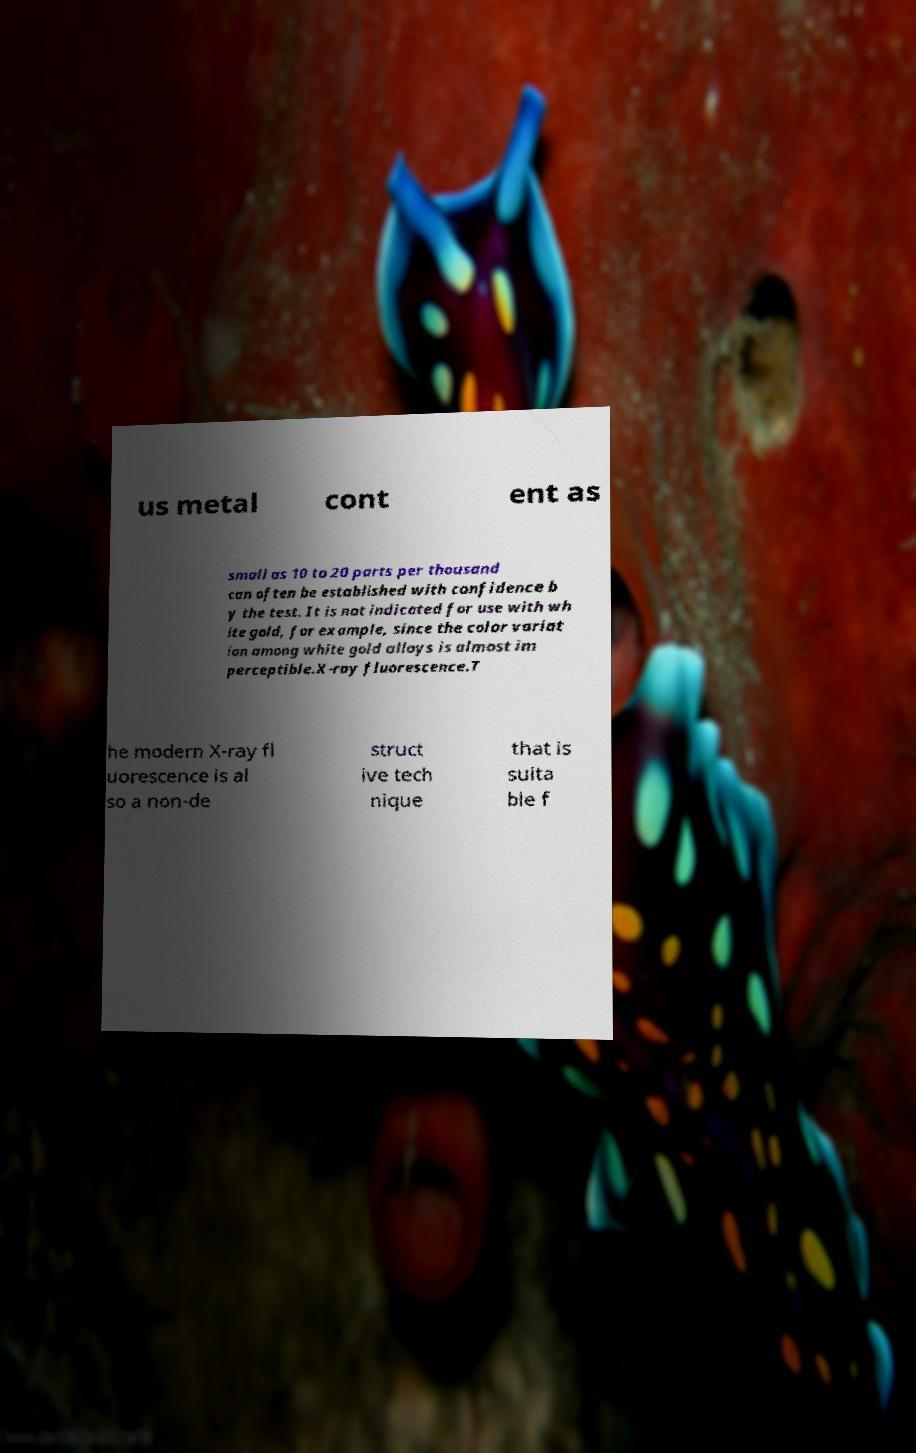Can you accurately transcribe the text from the provided image for me? us metal cont ent as small as 10 to 20 parts per thousand can often be established with confidence b y the test. It is not indicated for use with wh ite gold, for example, since the color variat ion among white gold alloys is almost im perceptible.X-ray fluorescence.T he modern X-ray fl uorescence is al so a non-de struct ive tech nique that is suita ble f 